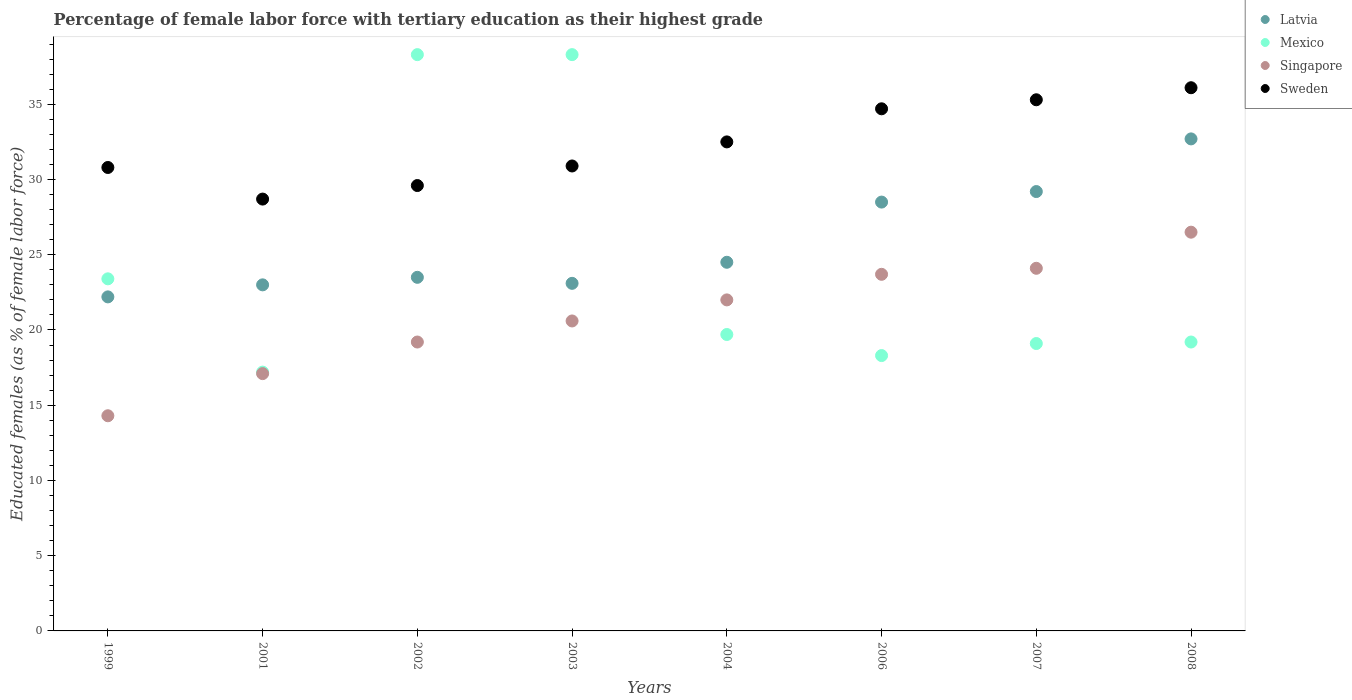How many different coloured dotlines are there?
Your answer should be compact. 4. Is the number of dotlines equal to the number of legend labels?
Give a very brief answer. Yes. What is the percentage of female labor force with tertiary education in Singapore in 1999?
Your response must be concise. 14.3. Across all years, what is the maximum percentage of female labor force with tertiary education in Singapore?
Make the answer very short. 26.5. Across all years, what is the minimum percentage of female labor force with tertiary education in Sweden?
Keep it short and to the point. 28.7. What is the total percentage of female labor force with tertiary education in Latvia in the graph?
Give a very brief answer. 206.7. What is the difference between the percentage of female labor force with tertiary education in Mexico in 2002 and that in 2006?
Make the answer very short. 20. What is the difference between the percentage of female labor force with tertiary education in Latvia in 2006 and the percentage of female labor force with tertiary education in Singapore in 2007?
Your answer should be very brief. 4.4. What is the average percentage of female labor force with tertiary education in Latvia per year?
Your answer should be compact. 25.84. In the year 2003, what is the difference between the percentage of female labor force with tertiary education in Latvia and percentage of female labor force with tertiary education in Mexico?
Offer a very short reply. -15.2. What is the ratio of the percentage of female labor force with tertiary education in Mexico in 2002 to that in 2003?
Ensure brevity in your answer.  1. Is the percentage of female labor force with tertiary education in Latvia in 1999 less than that in 2006?
Offer a terse response. Yes. Is the difference between the percentage of female labor force with tertiary education in Latvia in 2004 and 2007 greater than the difference between the percentage of female labor force with tertiary education in Mexico in 2004 and 2007?
Offer a very short reply. No. What is the difference between the highest and the second highest percentage of female labor force with tertiary education in Latvia?
Provide a short and direct response. 3.5. What is the difference between the highest and the lowest percentage of female labor force with tertiary education in Sweden?
Ensure brevity in your answer.  7.4. In how many years, is the percentage of female labor force with tertiary education in Singapore greater than the average percentage of female labor force with tertiary education in Singapore taken over all years?
Your response must be concise. 4. Is the sum of the percentage of female labor force with tertiary education in Sweden in 2006 and 2008 greater than the maximum percentage of female labor force with tertiary education in Latvia across all years?
Offer a very short reply. Yes. Does the percentage of female labor force with tertiary education in Latvia monotonically increase over the years?
Your answer should be very brief. No. Is the percentage of female labor force with tertiary education in Latvia strictly greater than the percentage of female labor force with tertiary education in Singapore over the years?
Your answer should be compact. Yes. Is the percentage of female labor force with tertiary education in Latvia strictly less than the percentage of female labor force with tertiary education in Singapore over the years?
Provide a succinct answer. No. How many years are there in the graph?
Your answer should be very brief. 8. What is the difference between two consecutive major ticks on the Y-axis?
Provide a short and direct response. 5. Are the values on the major ticks of Y-axis written in scientific E-notation?
Give a very brief answer. No. Does the graph contain any zero values?
Ensure brevity in your answer.  No. Does the graph contain grids?
Your answer should be very brief. No. What is the title of the graph?
Give a very brief answer. Percentage of female labor force with tertiary education as their highest grade. What is the label or title of the X-axis?
Your response must be concise. Years. What is the label or title of the Y-axis?
Provide a short and direct response. Educated females (as % of female labor force). What is the Educated females (as % of female labor force) of Latvia in 1999?
Offer a very short reply. 22.2. What is the Educated females (as % of female labor force) in Mexico in 1999?
Offer a very short reply. 23.4. What is the Educated females (as % of female labor force) of Singapore in 1999?
Give a very brief answer. 14.3. What is the Educated females (as % of female labor force) of Sweden in 1999?
Make the answer very short. 30.8. What is the Educated females (as % of female labor force) of Latvia in 2001?
Provide a short and direct response. 23. What is the Educated females (as % of female labor force) in Mexico in 2001?
Provide a short and direct response. 17.2. What is the Educated females (as % of female labor force) of Singapore in 2001?
Your response must be concise. 17.1. What is the Educated females (as % of female labor force) in Sweden in 2001?
Your answer should be compact. 28.7. What is the Educated females (as % of female labor force) in Mexico in 2002?
Ensure brevity in your answer.  38.3. What is the Educated females (as % of female labor force) of Singapore in 2002?
Offer a very short reply. 19.2. What is the Educated females (as % of female labor force) of Sweden in 2002?
Provide a short and direct response. 29.6. What is the Educated females (as % of female labor force) in Latvia in 2003?
Offer a terse response. 23.1. What is the Educated females (as % of female labor force) in Mexico in 2003?
Your response must be concise. 38.3. What is the Educated females (as % of female labor force) of Singapore in 2003?
Offer a very short reply. 20.6. What is the Educated females (as % of female labor force) in Sweden in 2003?
Offer a terse response. 30.9. What is the Educated females (as % of female labor force) of Mexico in 2004?
Your answer should be very brief. 19.7. What is the Educated females (as % of female labor force) of Singapore in 2004?
Provide a succinct answer. 22. What is the Educated females (as % of female labor force) of Sweden in 2004?
Ensure brevity in your answer.  32.5. What is the Educated females (as % of female labor force) in Mexico in 2006?
Ensure brevity in your answer.  18.3. What is the Educated females (as % of female labor force) of Singapore in 2006?
Your answer should be very brief. 23.7. What is the Educated females (as % of female labor force) in Sweden in 2006?
Your answer should be very brief. 34.7. What is the Educated females (as % of female labor force) of Latvia in 2007?
Offer a terse response. 29.2. What is the Educated females (as % of female labor force) in Mexico in 2007?
Your answer should be very brief. 19.1. What is the Educated females (as % of female labor force) in Singapore in 2007?
Provide a succinct answer. 24.1. What is the Educated females (as % of female labor force) of Sweden in 2007?
Offer a very short reply. 35.3. What is the Educated females (as % of female labor force) in Latvia in 2008?
Make the answer very short. 32.7. What is the Educated females (as % of female labor force) of Mexico in 2008?
Make the answer very short. 19.2. What is the Educated females (as % of female labor force) of Singapore in 2008?
Provide a succinct answer. 26.5. What is the Educated females (as % of female labor force) of Sweden in 2008?
Provide a short and direct response. 36.1. Across all years, what is the maximum Educated females (as % of female labor force) in Latvia?
Offer a very short reply. 32.7. Across all years, what is the maximum Educated females (as % of female labor force) in Mexico?
Make the answer very short. 38.3. Across all years, what is the maximum Educated females (as % of female labor force) of Sweden?
Your answer should be compact. 36.1. Across all years, what is the minimum Educated females (as % of female labor force) in Latvia?
Ensure brevity in your answer.  22.2. Across all years, what is the minimum Educated females (as % of female labor force) of Mexico?
Give a very brief answer. 17.2. Across all years, what is the minimum Educated females (as % of female labor force) of Singapore?
Provide a short and direct response. 14.3. Across all years, what is the minimum Educated females (as % of female labor force) of Sweden?
Make the answer very short. 28.7. What is the total Educated females (as % of female labor force) in Latvia in the graph?
Offer a terse response. 206.7. What is the total Educated females (as % of female labor force) in Mexico in the graph?
Keep it short and to the point. 193.5. What is the total Educated females (as % of female labor force) in Singapore in the graph?
Keep it short and to the point. 167.5. What is the total Educated females (as % of female labor force) in Sweden in the graph?
Provide a short and direct response. 258.6. What is the difference between the Educated females (as % of female labor force) in Latvia in 1999 and that in 2001?
Your answer should be very brief. -0.8. What is the difference between the Educated females (as % of female labor force) in Singapore in 1999 and that in 2001?
Offer a terse response. -2.8. What is the difference between the Educated females (as % of female labor force) of Mexico in 1999 and that in 2002?
Your response must be concise. -14.9. What is the difference between the Educated females (as % of female labor force) in Singapore in 1999 and that in 2002?
Make the answer very short. -4.9. What is the difference between the Educated females (as % of female labor force) in Latvia in 1999 and that in 2003?
Ensure brevity in your answer.  -0.9. What is the difference between the Educated females (as % of female labor force) of Mexico in 1999 and that in 2003?
Provide a short and direct response. -14.9. What is the difference between the Educated females (as % of female labor force) of Sweden in 1999 and that in 2003?
Make the answer very short. -0.1. What is the difference between the Educated females (as % of female labor force) in Sweden in 1999 and that in 2004?
Provide a short and direct response. -1.7. What is the difference between the Educated females (as % of female labor force) in Latvia in 1999 and that in 2006?
Offer a terse response. -6.3. What is the difference between the Educated females (as % of female labor force) of Singapore in 1999 and that in 2006?
Your response must be concise. -9.4. What is the difference between the Educated females (as % of female labor force) in Sweden in 1999 and that in 2006?
Your answer should be compact. -3.9. What is the difference between the Educated females (as % of female labor force) of Singapore in 1999 and that in 2007?
Keep it short and to the point. -9.8. What is the difference between the Educated females (as % of female labor force) of Mexico in 2001 and that in 2002?
Offer a very short reply. -21.1. What is the difference between the Educated females (as % of female labor force) in Singapore in 2001 and that in 2002?
Your answer should be compact. -2.1. What is the difference between the Educated females (as % of female labor force) in Mexico in 2001 and that in 2003?
Your answer should be compact. -21.1. What is the difference between the Educated females (as % of female labor force) in Singapore in 2001 and that in 2003?
Offer a very short reply. -3.5. What is the difference between the Educated females (as % of female labor force) in Sweden in 2001 and that in 2003?
Your response must be concise. -2.2. What is the difference between the Educated females (as % of female labor force) of Latvia in 2001 and that in 2004?
Ensure brevity in your answer.  -1.5. What is the difference between the Educated females (as % of female labor force) in Sweden in 2001 and that in 2004?
Your answer should be very brief. -3.8. What is the difference between the Educated females (as % of female labor force) in Singapore in 2001 and that in 2006?
Provide a short and direct response. -6.6. What is the difference between the Educated females (as % of female labor force) of Singapore in 2001 and that in 2007?
Make the answer very short. -7. What is the difference between the Educated females (as % of female labor force) in Sweden in 2001 and that in 2007?
Ensure brevity in your answer.  -6.6. What is the difference between the Educated females (as % of female labor force) in Latvia in 2001 and that in 2008?
Your answer should be compact. -9.7. What is the difference between the Educated females (as % of female labor force) in Mexico in 2001 and that in 2008?
Offer a very short reply. -2. What is the difference between the Educated females (as % of female labor force) of Sweden in 2002 and that in 2003?
Offer a terse response. -1.3. What is the difference between the Educated females (as % of female labor force) in Latvia in 2002 and that in 2004?
Offer a very short reply. -1. What is the difference between the Educated females (as % of female labor force) in Mexico in 2002 and that in 2004?
Your response must be concise. 18.6. What is the difference between the Educated females (as % of female labor force) of Singapore in 2002 and that in 2004?
Your answer should be compact. -2.8. What is the difference between the Educated females (as % of female labor force) of Sweden in 2002 and that in 2004?
Provide a short and direct response. -2.9. What is the difference between the Educated females (as % of female labor force) in Latvia in 2002 and that in 2006?
Give a very brief answer. -5. What is the difference between the Educated females (as % of female labor force) in Mexico in 2002 and that in 2006?
Your answer should be compact. 20. What is the difference between the Educated females (as % of female labor force) of Singapore in 2002 and that in 2006?
Your answer should be very brief. -4.5. What is the difference between the Educated females (as % of female labor force) in Sweden in 2002 and that in 2006?
Your answer should be very brief. -5.1. What is the difference between the Educated females (as % of female labor force) in Latvia in 2002 and that in 2007?
Your response must be concise. -5.7. What is the difference between the Educated females (as % of female labor force) in Mexico in 2002 and that in 2007?
Offer a very short reply. 19.2. What is the difference between the Educated females (as % of female labor force) of Singapore in 2002 and that in 2007?
Ensure brevity in your answer.  -4.9. What is the difference between the Educated females (as % of female labor force) of Sweden in 2002 and that in 2007?
Ensure brevity in your answer.  -5.7. What is the difference between the Educated females (as % of female labor force) in Mexico in 2003 and that in 2004?
Offer a terse response. 18.6. What is the difference between the Educated females (as % of female labor force) of Mexico in 2003 and that in 2006?
Make the answer very short. 20. What is the difference between the Educated females (as % of female labor force) in Singapore in 2003 and that in 2006?
Keep it short and to the point. -3.1. What is the difference between the Educated females (as % of female labor force) of Sweden in 2003 and that in 2006?
Your response must be concise. -3.8. What is the difference between the Educated females (as % of female labor force) of Mexico in 2003 and that in 2007?
Ensure brevity in your answer.  19.2. What is the difference between the Educated females (as % of female labor force) in Latvia in 2003 and that in 2008?
Offer a terse response. -9.6. What is the difference between the Educated females (as % of female labor force) in Latvia in 2004 and that in 2006?
Your answer should be compact. -4. What is the difference between the Educated females (as % of female labor force) of Mexico in 2004 and that in 2006?
Provide a succinct answer. 1.4. What is the difference between the Educated females (as % of female labor force) in Singapore in 2004 and that in 2006?
Give a very brief answer. -1.7. What is the difference between the Educated females (as % of female labor force) in Latvia in 2004 and that in 2007?
Provide a short and direct response. -4.7. What is the difference between the Educated females (as % of female labor force) of Sweden in 2004 and that in 2007?
Offer a terse response. -2.8. What is the difference between the Educated females (as % of female labor force) in Mexico in 2004 and that in 2008?
Offer a terse response. 0.5. What is the difference between the Educated females (as % of female labor force) in Singapore in 2004 and that in 2008?
Offer a terse response. -4.5. What is the difference between the Educated females (as % of female labor force) in Sweden in 2006 and that in 2007?
Your answer should be very brief. -0.6. What is the difference between the Educated females (as % of female labor force) of Sweden in 2006 and that in 2008?
Your answer should be compact. -1.4. What is the difference between the Educated females (as % of female labor force) of Latvia in 2007 and that in 2008?
Make the answer very short. -3.5. What is the difference between the Educated females (as % of female labor force) of Singapore in 2007 and that in 2008?
Offer a terse response. -2.4. What is the difference between the Educated females (as % of female labor force) of Latvia in 1999 and the Educated females (as % of female labor force) of Mexico in 2001?
Provide a short and direct response. 5. What is the difference between the Educated females (as % of female labor force) in Latvia in 1999 and the Educated females (as % of female labor force) in Sweden in 2001?
Make the answer very short. -6.5. What is the difference between the Educated females (as % of female labor force) in Mexico in 1999 and the Educated females (as % of female labor force) in Singapore in 2001?
Your response must be concise. 6.3. What is the difference between the Educated females (as % of female labor force) of Singapore in 1999 and the Educated females (as % of female labor force) of Sweden in 2001?
Provide a short and direct response. -14.4. What is the difference between the Educated females (as % of female labor force) of Latvia in 1999 and the Educated females (as % of female labor force) of Mexico in 2002?
Provide a succinct answer. -16.1. What is the difference between the Educated females (as % of female labor force) of Latvia in 1999 and the Educated females (as % of female labor force) of Singapore in 2002?
Your answer should be very brief. 3. What is the difference between the Educated females (as % of female labor force) in Latvia in 1999 and the Educated females (as % of female labor force) in Sweden in 2002?
Give a very brief answer. -7.4. What is the difference between the Educated females (as % of female labor force) in Mexico in 1999 and the Educated females (as % of female labor force) in Sweden in 2002?
Give a very brief answer. -6.2. What is the difference between the Educated females (as % of female labor force) in Singapore in 1999 and the Educated females (as % of female labor force) in Sweden in 2002?
Your response must be concise. -15.3. What is the difference between the Educated females (as % of female labor force) of Latvia in 1999 and the Educated females (as % of female labor force) of Mexico in 2003?
Your answer should be very brief. -16.1. What is the difference between the Educated females (as % of female labor force) in Singapore in 1999 and the Educated females (as % of female labor force) in Sweden in 2003?
Make the answer very short. -16.6. What is the difference between the Educated females (as % of female labor force) of Latvia in 1999 and the Educated females (as % of female labor force) of Mexico in 2004?
Keep it short and to the point. 2.5. What is the difference between the Educated females (as % of female labor force) in Mexico in 1999 and the Educated females (as % of female labor force) in Singapore in 2004?
Give a very brief answer. 1.4. What is the difference between the Educated females (as % of female labor force) of Mexico in 1999 and the Educated females (as % of female labor force) of Sweden in 2004?
Offer a very short reply. -9.1. What is the difference between the Educated females (as % of female labor force) of Singapore in 1999 and the Educated females (as % of female labor force) of Sweden in 2004?
Make the answer very short. -18.2. What is the difference between the Educated females (as % of female labor force) of Mexico in 1999 and the Educated females (as % of female labor force) of Singapore in 2006?
Your answer should be very brief. -0.3. What is the difference between the Educated females (as % of female labor force) in Mexico in 1999 and the Educated females (as % of female labor force) in Sweden in 2006?
Offer a very short reply. -11.3. What is the difference between the Educated females (as % of female labor force) of Singapore in 1999 and the Educated females (as % of female labor force) of Sweden in 2006?
Ensure brevity in your answer.  -20.4. What is the difference between the Educated females (as % of female labor force) of Latvia in 1999 and the Educated females (as % of female labor force) of Mexico in 2007?
Keep it short and to the point. 3.1. What is the difference between the Educated females (as % of female labor force) in Latvia in 1999 and the Educated females (as % of female labor force) in Singapore in 2007?
Offer a terse response. -1.9. What is the difference between the Educated females (as % of female labor force) in Latvia in 1999 and the Educated females (as % of female labor force) in Sweden in 2007?
Provide a short and direct response. -13.1. What is the difference between the Educated females (as % of female labor force) of Mexico in 1999 and the Educated females (as % of female labor force) of Sweden in 2007?
Make the answer very short. -11.9. What is the difference between the Educated females (as % of female labor force) of Latvia in 1999 and the Educated females (as % of female labor force) of Mexico in 2008?
Your answer should be compact. 3. What is the difference between the Educated females (as % of female labor force) in Latvia in 1999 and the Educated females (as % of female labor force) in Singapore in 2008?
Your answer should be very brief. -4.3. What is the difference between the Educated females (as % of female labor force) of Mexico in 1999 and the Educated females (as % of female labor force) of Singapore in 2008?
Offer a very short reply. -3.1. What is the difference between the Educated females (as % of female labor force) in Singapore in 1999 and the Educated females (as % of female labor force) in Sweden in 2008?
Your answer should be compact. -21.8. What is the difference between the Educated females (as % of female labor force) of Latvia in 2001 and the Educated females (as % of female labor force) of Mexico in 2002?
Your response must be concise. -15.3. What is the difference between the Educated females (as % of female labor force) in Latvia in 2001 and the Educated females (as % of female labor force) in Sweden in 2002?
Make the answer very short. -6.6. What is the difference between the Educated females (as % of female labor force) of Mexico in 2001 and the Educated females (as % of female labor force) of Singapore in 2002?
Offer a terse response. -2. What is the difference between the Educated females (as % of female labor force) in Mexico in 2001 and the Educated females (as % of female labor force) in Sweden in 2002?
Offer a very short reply. -12.4. What is the difference between the Educated females (as % of female labor force) in Singapore in 2001 and the Educated females (as % of female labor force) in Sweden in 2002?
Your response must be concise. -12.5. What is the difference between the Educated females (as % of female labor force) of Latvia in 2001 and the Educated females (as % of female labor force) of Mexico in 2003?
Offer a terse response. -15.3. What is the difference between the Educated females (as % of female labor force) in Mexico in 2001 and the Educated females (as % of female labor force) in Singapore in 2003?
Ensure brevity in your answer.  -3.4. What is the difference between the Educated females (as % of female labor force) in Mexico in 2001 and the Educated females (as % of female labor force) in Sweden in 2003?
Your answer should be very brief. -13.7. What is the difference between the Educated females (as % of female labor force) in Singapore in 2001 and the Educated females (as % of female labor force) in Sweden in 2003?
Provide a succinct answer. -13.8. What is the difference between the Educated females (as % of female labor force) in Latvia in 2001 and the Educated females (as % of female labor force) in Singapore in 2004?
Give a very brief answer. 1. What is the difference between the Educated females (as % of female labor force) in Latvia in 2001 and the Educated females (as % of female labor force) in Sweden in 2004?
Offer a terse response. -9.5. What is the difference between the Educated females (as % of female labor force) in Mexico in 2001 and the Educated females (as % of female labor force) in Sweden in 2004?
Offer a terse response. -15.3. What is the difference between the Educated females (as % of female labor force) in Singapore in 2001 and the Educated females (as % of female labor force) in Sweden in 2004?
Your answer should be compact. -15.4. What is the difference between the Educated females (as % of female labor force) of Latvia in 2001 and the Educated females (as % of female labor force) of Sweden in 2006?
Provide a short and direct response. -11.7. What is the difference between the Educated females (as % of female labor force) of Mexico in 2001 and the Educated females (as % of female labor force) of Sweden in 2006?
Your answer should be compact. -17.5. What is the difference between the Educated females (as % of female labor force) of Singapore in 2001 and the Educated females (as % of female labor force) of Sweden in 2006?
Your answer should be very brief. -17.6. What is the difference between the Educated females (as % of female labor force) in Latvia in 2001 and the Educated females (as % of female labor force) in Singapore in 2007?
Your answer should be compact. -1.1. What is the difference between the Educated females (as % of female labor force) in Mexico in 2001 and the Educated females (as % of female labor force) in Singapore in 2007?
Ensure brevity in your answer.  -6.9. What is the difference between the Educated females (as % of female labor force) of Mexico in 2001 and the Educated females (as % of female labor force) of Sweden in 2007?
Give a very brief answer. -18.1. What is the difference between the Educated females (as % of female labor force) of Singapore in 2001 and the Educated females (as % of female labor force) of Sweden in 2007?
Ensure brevity in your answer.  -18.2. What is the difference between the Educated females (as % of female labor force) of Latvia in 2001 and the Educated females (as % of female labor force) of Singapore in 2008?
Provide a succinct answer. -3.5. What is the difference between the Educated females (as % of female labor force) in Latvia in 2001 and the Educated females (as % of female labor force) in Sweden in 2008?
Offer a terse response. -13.1. What is the difference between the Educated females (as % of female labor force) of Mexico in 2001 and the Educated females (as % of female labor force) of Sweden in 2008?
Keep it short and to the point. -18.9. What is the difference between the Educated females (as % of female labor force) in Latvia in 2002 and the Educated females (as % of female labor force) in Mexico in 2003?
Your answer should be compact. -14.8. What is the difference between the Educated females (as % of female labor force) in Latvia in 2002 and the Educated females (as % of female labor force) in Mexico in 2004?
Ensure brevity in your answer.  3.8. What is the difference between the Educated females (as % of female labor force) in Latvia in 2002 and the Educated females (as % of female labor force) in Singapore in 2004?
Offer a terse response. 1.5. What is the difference between the Educated females (as % of female labor force) in Mexico in 2002 and the Educated females (as % of female labor force) in Singapore in 2004?
Provide a succinct answer. 16.3. What is the difference between the Educated females (as % of female labor force) of Mexico in 2002 and the Educated females (as % of female labor force) of Sweden in 2004?
Your response must be concise. 5.8. What is the difference between the Educated females (as % of female labor force) in Latvia in 2002 and the Educated females (as % of female labor force) in Mexico in 2006?
Offer a terse response. 5.2. What is the difference between the Educated females (as % of female labor force) in Latvia in 2002 and the Educated females (as % of female labor force) in Sweden in 2006?
Offer a terse response. -11.2. What is the difference between the Educated females (as % of female labor force) of Singapore in 2002 and the Educated females (as % of female labor force) of Sweden in 2006?
Provide a succinct answer. -15.5. What is the difference between the Educated females (as % of female labor force) in Latvia in 2002 and the Educated females (as % of female labor force) in Mexico in 2007?
Keep it short and to the point. 4.4. What is the difference between the Educated females (as % of female labor force) of Mexico in 2002 and the Educated females (as % of female labor force) of Singapore in 2007?
Your answer should be very brief. 14.2. What is the difference between the Educated females (as % of female labor force) of Singapore in 2002 and the Educated females (as % of female labor force) of Sweden in 2007?
Your answer should be very brief. -16.1. What is the difference between the Educated females (as % of female labor force) of Latvia in 2002 and the Educated females (as % of female labor force) of Mexico in 2008?
Your response must be concise. 4.3. What is the difference between the Educated females (as % of female labor force) in Latvia in 2002 and the Educated females (as % of female labor force) in Sweden in 2008?
Provide a succinct answer. -12.6. What is the difference between the Educated females (as % of female labor force) in Mexico in 2002 and the Educated females (as % of female labor force) in Singapore in 2008?
Offer a terse response. 11.8. What is the difference between the Educated females (as % of female labor force) of Singapore in 2002 and the Educated females (as % of female labor force) of Sweden in 2008?
Your answer should be very brief. -16.9. What is the difference between the Educated females (as % of female labor force) of Latvia in 2003 and the Educated females (as % of female labor force) of Mexico in 2004?
Provide a short and direct response. 3.4. What is the difference between the Educated females (as % of female labor force) of Latvia in 2003 and the Educated females (as % of female labor force) of Sweden in 2004?
Your answer should be compact. -9.4. What is the difference between the Educated females (as % of female labor force) in Mexico in 2003 and the Educated females (as % of female labor force) in Sweden in 2004?
Your answer should be very brief. 5.8. What is the difference between the Educated females (as % of female labor force) of Singapore in 2003 and the Educated females (as % of female labor force) of Sweden in 2004?
Keep it short and to the point. -11.9. What is the difference between the Educated females (as % of female labor force) of Latvia in 2003 and the Educated females (as % of female labor force) of Singapore in 2006?
Make the answer very short. -0.6. What is the difference between the Educated females (as % of female labor force) in Singapore in 2003 and the Educated females (as % of female labor force) in Sweden in 2006?
Provide a succinct answer. -14.1. What is the difference between the Educated females (as % of female labor force) in Latvia in 2003 and the Educated females (as % of female labor force) in Mexico in 2007?
Give a very brief answer. 4. What is the difference between the Educated females (as % of female labor force) of Latvia in 2003 and the Educated females (as % of female labor force) of Sweden in 2007?
Give a very brief answer. -12.2. What is the difference between the Educated females (as % of female labor force) in Mexico in 2003 and the Educated females (as % of female labor force) in Sweden in 2007?
Ensure brevity in your answer.  3. What is the difference between the Educated females (as % of female labor force) in Singapore in 2003 and the Educated females (as % of female labor force) in Sweden in 2007?
Your answer should be very brief. -14.7. What is the difference between the Educated females (as % of female labor force) of Latvia in 2003 and the Educated females (as % of female labor force) of Singapore in 2008?
Offer a terse response. -3.4. What is the difference between the Educated females (as % of female labor force) of Mexico in 2003 and the Educated females (as % of female labor force) of Sweden in 2008?
Offer a terse response. 2.2. What is the difference between the Educated females (as % of female labor force) of Singapore in 2003 and the Educated females (as % of female labor force) of Sweden in 2008?
Keep it short and to the point. -15.5. What is the difference between the Educated females (as % of female labor force) of Latvia in 2004 and the Educated females (as % of female labor force) of Singapore in 2006?
Make the answer very short. 0.8. What is the difference between the Educated females (as % of female labor force) of Latvia in 2004 and the Educated females (as % of female labor force) of Sweden in 2006?
Provide a short and direct response. -10.2. What is the difference between the Educated females (as % of female labor force) in Mexico in 2004 and the Educated females (as % of female labor force) in Singapore in 2006?
Provide a succinct answer. -4. What is the difference between the Educated females (as % of female labor force) in Latvia in 2004 and the Educated females (as % of female labor force) in Mexico in 2007?
Keep it short and to the point. 5.4. What is the difference between the Educated females (as % of female labor force) of Latvia in 2004 and the Educated females (as % of female labor force) of Sweden in 2007?
Provide a short and direct response. -10.8. What is the difference between the Educated females (as % of female labor force) of Mexico in 2004 and the Educated females (as % of female labor force) of Sweden in 2007?
Provide a succinct answer. -15.6. What is the difference between the Educated females (as % of female labor force) in Singapore in 2004 and the Educated females (as % of female labor force) in Sweden in 2007?
Your response must be concise. -13.3. What is the difference between the Educated females (as % of female labor force) in Latvia in 2004 and the Educated females (as % of female labor force) in Sweden in 2008?
Offer a terse response. -11.6. What is the difference between the Educated females (as % of female labor force) of Mexico in 2004 and the Educated females (as % of female labor force) of Sweden in 2008?
Provide a short and direct response. -16.4. What is the difference between the Educated females (as % of female labor force) in Singapore in 2004 and the Educated females (as % of female labor force) in Sweden in 2008?
Give a very brief answer. -14.1. What is the difference between the Educated females (as % of female labor force) of Latvia in 2006 and the Educated females (as % of female labor force) of Sweden in 2007?
Your answer should be compact. -6.8. What is the difference between the Educated females (as % of female labor force) in Mexico in 2006 and the Educated females (as % of female labor force) in Singapore in 2007?
Your answer should be very brief. -5.8. What is the difference between the Educated females (as % of female labor force) of Singapore in 2006 and the Educated females (as % of female labor force) of Sweden in 2007?
Provide a short and direct response. -11.6. What is the difference between the Educated females (as % of female labor force) of Latvia in 2006 and the Educated females (as % of female labor force) of Mexico in 2008?
Make the answer very short. 9.3. What is the difference between the Educated females (as % of female labor force) in Latvia in 2006 and the Educated females (as % of female labor force) in Sweden in 2008?
Your answer should be compact. -7.6. What is the difference between the Educated females (as % of female labor force) in Mexico in 2006 and the Educated females (as % of female labor force) in Singapore in 2008?
Give a very brief answer. -8.2. What is the difference between the Educated females (as % of female labor force) of Mexico in 2006 and the Educated females (as % of female labor force) of Sweden in 2008?
Your response must be concise. -17.8. What is the difference between the Educated females (as % of female labor force) of Latvia in 2007 and the Educated females (as % of female labor force) of Mexico in 2008?
Ensure brevity in your answer.  10. What is the difference between the Educated females (as % of female labor force) of Mexico in 2007 and the Educated females (as % of female labor force) of Singapore in 2008?
Offer a terse response. -7.4. What is the difference between the Educated females (as % of female labor force) in Mexico in 2007 and the Educated females (as % of female labor force) in Sweden in 2008?
Offer a very short reply. -17. What is the difference between the Educated females (as % of female labor force) of Singapore in 2007 and the Educated females (as % of female labor force) of Sweden in 2008?
Your answer should be compact. -12. What is the average Educated females (as % of female labor force) of Latvia per year?
Make the answer very short. 25.84. What is the average Educated females (as % of female labor force) in Mexico per year?
Your answer should be compact. 24.19. What is the average Educated females (as % of female labor force) in Singapore per year?
Offer a very short reply. 20.94. What is the average Educated females (as % of female labor force) of Sweden per year?
Ensure brevity in your answer.  32.33. In the year 1999, what is the difference between the Educated females (as % of female labor force) of Latvia and Educated females (as % of female labor force) of Singapore?
Offer a very short reply. 7.9. In the year 1999, what is the difference between the Educated females (as % of female labor force) of Latvia and Educated females (as % of female labor force) of Sweden?
Offer a very short reply. -8.6. In the year 1999, what is the difference between the Educated females (as % of female labor force) in Singapore and Educated females (as % of female labor force) in Sweden?
Make the answer very short. -16.5. In the year 2001, what is the difference between the Educated females (as % of female labor force) of Latvia and Educated females (as % of female labor force) of Mexico?
Your answer should be compact. 5.8. In the year 2001, what is the difference between the Educated females (as % of female labor force) in Latvia and Educated females (as % of female labor force) in Singapore?
Your answer should be very brief. 5.9. In the year 2001, what is the difference between the Educated females (as % of female labor force) in Latvia and Educated females (as % of female labor force) in Sweden?
Offer a very short reply. -5.7. In the year 2001, what is the difference between the Educated females (as % of female labor force) in Mexico and Educated females (as % of female labor force) in Singapore?
Keep it short and to the point. 0.1. In the year 2001, what is the difference between the Educated females (as % of female labor force) in Mexico and Educated females (as % of female labor force) in Sweden?
Offer a terse response. -11.5. In the year 2001, what is the difference between the Educated females (as % of female labor force) in Singapore and Educated females (as % of female labor force) in Sweden?
Your answer should be very brief. -11.6. In the year 2002, what is the difference between the Educated females (as % of female labor force) in Latvia and Educated females (as % of female labor force) in Mexico?
Your answer should be compact. -14.8. In the year 2002, what is the difference between the Educated females (as % of female labor force) in Mexico and Educated females (as % of female labor force) in Sweden?
Your answer should be very brief. 8.7. In the year 2002, what is the difference between the Educated females (as % of female labor force) of Singapore and Educated females (as % of female labor force) of Sweden?
Offer a very short reply. -10.4. In the year 2003, what is the difference between the Educated females (as % of female labor force) of Latvia and Educated females (as % of female labor force) of Mexico?
Give a very brief answer. -15.2. In the year 2003, what is the difference between the Educated females (as % of female labor force) in Mexico and Educated females (as % of female labor force) in Sweden?
Your answer should be very brief. 7.4. In the year 2003, what is the difference between the Educated females (as % of female labor force) in Singapore and Educated females (as % of female labor force) in Sweden?
Your answer should be compact. -10.3. In the year 2004, what is the difference between the Educated females (as % of female labor force) in Latvia and Educated females (as % of female labor force) in Singapore?
Your answer should be compact. 2.5. In the year 2004, what is the difference between the Educated females (as % of female labor force) in Latvia and Educated females (as % of female labor force) in Sweden?
Make the answer very short. -8. In the year 2004, what is the difference between the Educated females (as % of female labor force) of Mexico and Educated females (as % of female labor force) of Singapore?
Provide a short and direct response. -2.3. In the year 2004, what is the difference between the Educated females (as % of female labor force) of Mexico and Educated females (as % of female labor force) of Sweden?
Give a very brief answer. -12.8. In the year 2004, what is the difference between the Educated females (as % of female labor force) in Singapore and Educated females (as % of female labor force) in Sweden?
Ensure brevity in your answer.  -10.5. In the year 2006, what is the difference between the Educated females (as % of female labor force) in Latvia and Educated females (as % of female labor force) in Singapore?
Offer a terse response. 4.8. In the year 2006, what is the difference between the Educated females (as % of female labor force) of Latvia and Educated females (as % of female labor force) of Sweden?
Your response must be concise. -6.2. In the year 2006, what is the difference between the Educated females (as % of female labor force) of Mexico and Educated females (as % of female labor force) of Sweden?
Make the answer very short. -16.4. In the year 2006, what is the difference between the Educated females (as % of female labor force) in Singapore and Educated females (as % of female labor force) in Sweden?
Provide a succinct answer. -11. In the year 2007, what is the difference between the Educated females (as % of female labor force) of Latvia and Educated females (as % of female labor force) of Singapore?
Your response must be concise. 5.1. In the year 2007, what is the difference between the Educated females (as % of female labor force) of Mexico and Educated females (as % of female labor force) of Sweden?
Offer a terse response. -16.2. In the year 2007, what is the difference between the Educated females (as % of female labor force) of Singapore and Educated females (as % of female labor force) of Sweden?
Keep it short and to the point. -11.2. In the year 2008, what is the difference between the Educated females (as % of female labor force) in Latvia and Educated females (as % of female labor force) in Mexico?
Provide a succinct answer. 13.5. In the year 2008, what is the difference between the Educated females (as % of female labor force) in Latvia and Educated females (as % of female labor force) in Singapore?
Your answer should be very brief. 6.2. In the year 2008, what is the difference between the Educated females (as % of female labor force) in Latvia and Educated females (as % of female labor force) in Sweden?
Make the answer very short. -3.4. In the year 2008, what is the difference between the Educated females (as % of female labor force) in Mexico and Educated females (as % of female labor force) in Singapore?
Offer a terse response. -7.3. In the year 2008, what is the difference between the Educated females (as % of female labor force) in Mexico and Educated females (as % of female labor force) in Sweden?
Offer a very short reply. -16.9. In the year 2008, what is the difference between the Educated females (as % of female labor force) in Singapore and Educated females (as % of female labor force) in Sweden?
Ensure brevity in your answer.  -9.6. What is the ratio of the Educated females (as % of female labor force) of Latvia in 1999 to that in 2001?
Offer a very short reply. 0.97. What is the ratio of the Educated females (as % of female labor force) in Mexico in 1999 to that in 2001?
Ensure brevity in your answer.  1.36. What is the ratio of the Educated females (as % of female labor force) in Singapore in 1999 to that in 2001?
Ensure brevity in your answer.  0.84. What is the ratio of the Educated females (as % of female labor force) of Sweden in 1999 to that in 2001?
Provide a succinct answer. 1.07. What is the ratio of the Educated females (as % of female labor force) in Latvia in 1999 to that in 2002?
Give a very brief answer. 0.94. What is the ratio of the Educated females (as % of female labor force) of Mexico in 1999 to that in 2002?
Provide a succinct answer. 0.61. What is the ratio of the Educated females (as % of female labor force) of Singapore in 1999 to that in 2002?
Provide a short and direct response. 0.74. What is the ratio of the Educated females (as % of female labor force) in Sweden in 1999 to that in 2002?
Offer a very short reply. 1.04. What is the ratio of the Educated females (as % of female labor force) in Mexico in 1999 to that in 2003?
Offer a terse response. 0.61. What is the ratio of the Educated females (as % of female labor force) in Singapore in 1999 to that in 2003?
Your response must be concise. 0.69. What is the ratio of the Educated females (as % of female labor force) of Sweden in 1999 to that in 2003?
Make the answer very short. 1. What is the ratio of the Educated females (as % of female labor force) in Latvia in 1999 to that in 2004?
Offer a very short reply. 0.91. What is the ratio of the Educated females (as % of female labor force) of Mexico in 1999 to that in 2004?
Your answer should be compact. 1.19. What is the ratio of the Educated females (as % of female labor force) of Singapore in 1999 to that in 2004?
Provide a succinct answer. 0.65. What is the ratio of the Educated females (as % of female labor force) in Sweden in 1999 to that in 2004?
Your answer should be very brief. 0.95. What is the ratio of the Educated females (as % of female labor force) in Latvia in 1999 to that in 2006?
Provide a succinct answer. 0.78. What is the ratio of the Educated females (as % of female labor force) of Mexico in 1999 to that in 2006?
Provide a succinct answer. 1.28. What is the ratio of the Educated females (as % of female labor force) of Singapore in 1999 to that in 2006?
Offer a terse response. 0.6. What is the ratio of the Educated females (as % of female labor force) of Sweden in 1999 to that in 2006?
Your response must be concise. 0.89. What is the ratio of the Educated females (as % of female labor force) in Latvia in 1999 to that in 2007?
Your answer should be very brief. 0.76. What is the ratio of the Educated females (as % of female labor force) in Mexico in 1999 to that in 2007?
Your answer should be very brief. 1.23. What is the ratio of the Educated females (as % of female labor force) of Singapore in 1999 to that in 2007?
Provide a short and direct response. 0.59. What is the ratio of the Educated females (as % of female labor force) in Sweden in 1999 to that in 2007?
Your answer should be very brief. 0.87. What is the ratio of the Educated females (as % of female labor force) in Latvia in 1999 to that in 2008?
Your answer should be very brief. 0.68. What is the ratio of the Educated females (as % of female labor force) in Mexico in 1999 to that in 2008?
Provide a short and direct response. 1.22. What is the ratio of the Educated females (as % of female labor force) of Singapore in 1999 to that in 2008?
Offer a terse response. 0.54. What is the ratio of the Educated females (as % of female labor force) of Sweden in 1999 to that in 2008?
Ensure brevity in your answer.  0.85. What is the ratio of the Educated females (as % of female labor force) of Latvia in 2001 to that in 2002?
Your answer should be very brief. 0.98. What is the ratio of the Educated females (as % of female labor force) of Mexico in 2001 to that in 2002?
Give a very brief answer. 0.45. What is the ratio of the Educated females (as % of female labor force) of Singapore in 2001 to that in 2002?
Make the answer very short. 0.89. What is the ratio of the Educated females (as % of female labor force) in Sweden in 2001 to that in 2002?
Your answer should be compact. 0.97. What is the ratio of the Educated females (as % of female labor force) in Latvia in 2001 to that in 2003?
Provide a succinct answer. 1. What is the ratio of the Educated females (as % of female labor force) of Mexico in 2001 to that in 2003?
Your response must be concise. 0.45. What is the ratio of the Educated females (as % of female labor force) of Singapore in 2001 to that in 2003?
Offer a very short reply. 0.83. What is the ratio of the Educated females (as % of female labor force) in Sweden in 2001 to that in 2003?
Your response must be concise. 0.93. What is the ratio of the Educated females (as % of female labor force) in Latvia in 2001 to that in 2004?
Your answer should be very brief. 0.94. What is the ratio of the Educated females (as % of female labor force) of Mexico in 2001 to that in 2004?
Provide a succinct answer. 0.87. What is the ratio of the Educated females (as % of female labor force) in Singapore in 2001 to that in 2004?
Offer a very short reply. 0.78. What is the ratio of the Educated females (as % of female labor force) in Sweden in 2001 to that in 2004?
Your response must be concise. 0.88. What is the ratio of the Educated females (as % of female labor force) of Latvia in 2001 to that in 2006?
Offer a very short reply. 0.81. What is the ratio of the Educated females (as % of female labor force) of Mexico in 2001 to that in 2006?
Provide a succinct answer. 0.94. What is the ratio of the Educated females (as % of female labor force) of Singapore in 2001 to that in 2006?
Provide a succinct answer. 0.72. What is the ratio of the Educated females (as % of female labor force) in Sweden in 2001 to that in 2006?
Ensure brevity in your answer.  0.83. What is the ratio of the Educated females (as % of female labor force) of Latvia in 2001 to that in 2007?
Your answer should be very brief. 0.79. What is the ratio of the Educated females (as % of female labor force) in Mexico in 2001 to that in 2007?
Offer a very short reply. 0.9. What is the ratio of the Educated females (as % of female labor force) in Singapore in 2001 to that in 2007?
Your response must be concise. 0.71. What is the ratio of the Educated females (as % of female labor force) of Sweden in 2001 to that in 2007?
Offer a very short reply. 0.81. What is the ratio of the Educated females (as % of female labor force) in Latvia in 2001 to that in 2008?
Provide a succinct answer. 0.7. What is the ratio of the Educated females (as % of female labor force) in Mexico in 2001 to that in 2008?
Your answer should be compact. 0.9. What is the ratio of the Educated females (as % of female labor force) in Singapore in 2001 to that in 2008?
Your response must be concise. 0.65. What is the ratio of the Educated females (as % of female labor force) of Sweden in 2001 to that in 2008?
Provide a short and direct response. 0.8. What is the ratio of the Educated females (as % of female labor force) of Latvia in 2002 to that in 2003?
Give a very brief answer. 1.02. What is the ratio of the Educated females (as % of female labor force) of Mexico in 2002 to that in 2003?
Provide a short and direct response. 1. What is the ratio of the Educated females (as % of female labor force) in Singapore in 2002 to that in 2003?
Ensure brevity in your answer.  0.93. What is the ratio of the Educated females (as % of female labor force) in Sweden in 2002 to that in 2003?
Offer a very short reply. 0.96. What is the ratio of the Educated females (as % of female labor force) of Latvia in 2002 to that in 2004?
Ensure brevity in your answer.  0.96. What is the ratio of the Educated females (as % of female labor force) in Mexico in 2002 to that in 2004?
Offer a very short reply. 1.94. What is the ratio of the Educated females (as % of female labor force) in Singapore in 2002 to that in 2004?
Your answer should be compact. 0.87. What is the ratio of the Educated females (as % of female labor force) of Sweden in 2002 to that in 2004?
Make the answer very short. 0.91. What is the ratio of the Educated females (as % of female labor force) of Latvia in 2002 to that in 2006?
Keep it short and to the point. 0.82. What is the ratio of the Educated females (as % of female labor force) of Mexico in 2002 to that in 2006?
Give a very brief answer. 2.09. What is the ratio of the Educated females (as % of female labor force) of Singapore in 2002 to that in 2006?
Make the answer very short. 0.81. What is the ratio of the Educated females (as % of female labor force) of Sweden in 2002 to that in 2006?
Give a very brief answer. 0.85. What is the ratio of the Educated females (as % of female labor force) of Latvia in 2002 to that in 2007?
Ensure brevity in your answer.  0.8. What is the ratio of the Educated females (as % of female labor force) of Mexico in 2002 to that in 2007?
Your answer should be compact. 2.01. What is the ratio of the Educated females (as % of female labor force) in Singapore in 2002 to that in 2007?
Provide a short and direct response. 0.8. What is the ratio of the Educated females (as % of female labor force) of Sweden in 2002 to that in 2007?
Your response must be concise. 0.84. What is the ratio of the Educated females (as % of female labor force) in Latvia in 2002 to that in 2008?
Offer a very short reply. 0.72. What is the ratio of the Educated females (as % of female labor force) in Mexico in 2002 to that in 2008?
Make the answer very short. 1.99. What is the ratio of the Educated females (as % of female labor force) in Singapore in 2002 to that in 2008?
Provide a short and direct response. 0.72. What is the ratio of the Educated females (as % of female labor force) in Sweden in 2002 to that in 2008?
Give a very brief answer. 0.82. What is the ratio of the Educated females (as % of female labor force) in Latvia in 2003 to that in 2004?
Ensure brevity in your answer.  0.94. What is the ratio of the Educated females (as % of female labor force) in Mexico in 2003 to that in 2004?
Give a very brief answer. 1.94. What is the ratio of the Educated females (as % of female labor force) of Singapore in 2003 to that in 2004?
Give a very brief answer. 0.94. What is the ratio of the Educated females (as % of female labor force) in Sweden in 2003 to that in 2004?
Provide a succinct answer. 0.95. What is the ratio of the Educated females (as % of female labor force) in Latvia in 2003 to that in 2006?
Provide a short and direct response. 0.81. What is the ratio of the Educated females (as % of female labor force) in Mexico in 2003 to that in 2006?
Make the answer very short. 2.09. What is the ratio of the Educated females (as % of female labor force) in Singapore in 2003 to that in 2006?
Your answer should be very brief. 0.87. What is the ratio of the Educated females (as % of female labor force) of Sweden in 2003 to that in 2006?
Offer a terse response. 0.89. What is the ratio of the Educated females (as % of female labor force) of Latvia in 2003 to that in 2007?
Make the answer very short. 0.79. What is the ratio of the Educated females (as % of female labor force) in Mexico in 2003 to that in 2007?
Make the answer very short. 2.01. What is the ratio of the Educated females (as % of female labor force) of Singapore in 2003 to that in 2007?
Offer a very short reply. 0.85. What is the ratio of the Educated females (as % of female labor force) of Sweden in 2003 to that in 2007?
Offer a terse response. 0.88. What is the ratio of the Educated females (as % of female labor force) in Latvia in 2003 to that in 2008?
Offer a terse response. 0.71. What is the ratio of the Educated females (as % of female labor force) of Mexico in 2003 to that in 2008?
Your response must be concise. 1.99. What is the ratio of the Educated females (as % of female labor force) of Singapore in 2003 to that in 2008?
Ensure brevity in your answer.  0.78. What is the ratio of the Educated females (as % of female labor force) in Sweden in 2003 to that in 2008?
Provide a succinct answer. 0.86. What is the ratio of the Educated females (as % of female labor force) in Latvia in 2004 to that in 2006?
Make the answer very short. 0.86. What is the ratio of the Educated females (as % of female labor force) of Mexico in 2004 to that in 2006?
Offer a terse response. 1.08. What is the ratio of the Educated females (as % of female labor force) in Singapore in 2004 to that in 2006?
Give a very brief answer. 0.93. What is the ratio of the Educated females (as % of female labor force) of Sweden in 2004 to that in 2006?
Your answer should be very brief. 0.94. What is the ratio of the Educated females (as % of female labor force) of Latvia in 2004 to that in 2007?
Give a very brief answer. 0.84. What is the ratio of the Educated females (as % of female labor force) in Mexico in 2004 to that in 2007?
Offer a terse response. 1.03. What is the ratio of the Educated females (as % of female labor force) in Singapore in 2004 to that in 2007?
Provide a short and direct response. 0.91. What is the ratio of the Educated females (as % of female labor force) in Sweden in 2004 to that in 2007?
Your answer should be very brief. 0.92. What is the ratio of the Educated females (as % of female labor force) in Latvia in 2004 to that in 2008?
Your answer should be very brief. 0.75. What is the ratio of the Educated females (as % of female labor force) in Mexico in 2004 to that in 2008?
Ensure brevity in your answer.  1.03. What is the ratio of the Educated females (as % of female labor force) in Singapore in 2004 to that in 2008?
Your answer should be very brief. 0.83. What is the ratio of the Educated females (as % of female labor force) in Sweden in 2004 to that in 2008?
Provide a succinct answer. 0.9. What is the ratio of the Educated females (as % of female labor force) in Latvia in 2006 to that in 2007?
Provide a short and direct response. 0.98. What is the ratio of the Educated females (as % of female labor force) in Mexico in 2006 to that in 2007?
Your response must be concise. 0.96. What is the ratio of the Educated females (as % of female labor force) of Singapore in 2006 to that in 2007?
Provide a succinct answer. 0.98. What is the ratio of the Educated females (as % of female labor force) in Latvia in 2006 to that in 2008?
Your answer should be compact. 0.87. What is the ratio of the Educated females (as % of female labor force) in Mexico in 2006 to that in 2008?
Provide a short and direct response. 0.95. What is the ratio of the Educated females (as % of female labor force) in Singapore in 2006 to that in 2008?
Your answer should be compact. 0.89. What is the ratio of the Educated females (as % of female labor force) in Sweden in 2006 to that in 2008?
Your answer should be very brief. 0.96. What is the ratio of the Educated females (as % of female labor force) in Latvia in 2007 to that in 2008?
Give a very brief answer. 0.89. What is the ratio of the Educated females (as % of female labor force) of Singapore in 2007 to that in 2008?
Provide a short and direct response. 0.91. What is the ratio of the Educated females (as % of female labor force) in Sweden in 2007 to that in 2008?
Keep it short and to the point. 0.98. What is the difference between the highest and the second highest Educated females (as % of female labor force) in Singapore?
Provide a short and direct response. 2.4. What is the difference between the highest and the second highest Educated females (as % of female labor force) of Sweden?
Make the answer very short. 0.8. What is the difference between the highest and the lowest Educated females (as % of female labor force) of Latvia?
Give a very brief answer. 10.5. What is the difference between the highest and the lowest Educated females (as % of female labor force) in Mexico?
Your answer should be compact. 21.1. What is the difference between the highest and the lowest Educated females (as % of female labor force) in Singapore?
Keep it short and to the point. 12.2. 